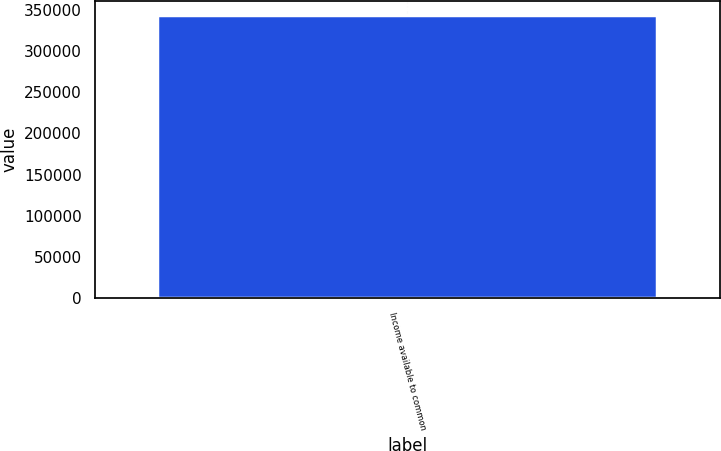<chart> <loc_0><loc_0><loc_500><loc_500><bar_chart><fcel>Income available to common<nl><fcel>343653<nl></chart> 